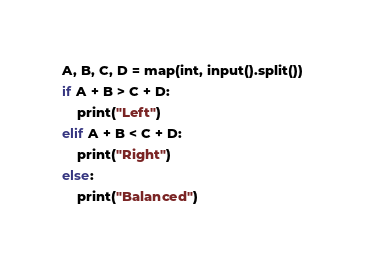Convert code to text. <code><loc_0><loc_0><loc_500><loc_500><_Python_>A, B, C, D = map(int, input().split())
if A + B > C + D:
    print("Left")
elif A + B < C + D:
    print("Right")
else:
    print("Balanced")</code> 